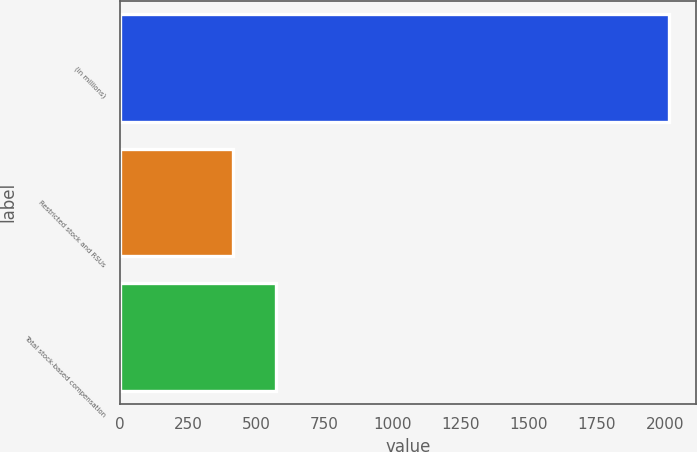<chart> <loc_0><loc_0><loc_500><loc_500><bar_chart><fcel>(in millions)<fcel>Restricted stock and RSUs<fcel>Total stock-based compensation<nl><fcel>2013<fcel>415<fcel>574.8<nl></chart> 